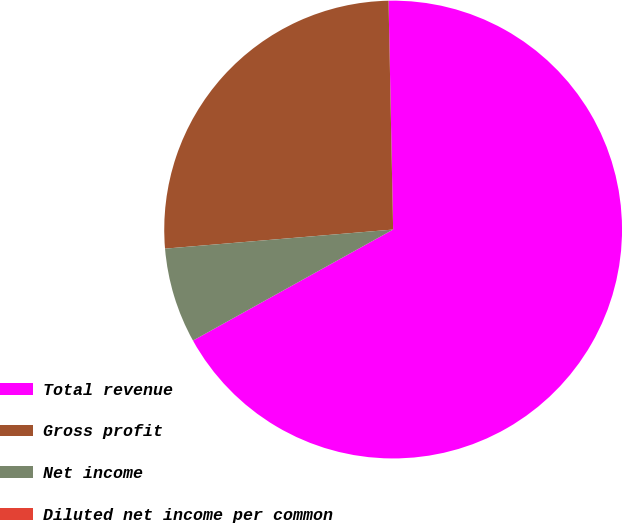Convert chart to OTSL. <chart><loc_0><loc_0><loc_500><loc_500><pie_chart><fcel>Total revenue<fcel>Gross profit<fcel>Net income<fcel>Diluted net income per common<nl><fcel>67.26%<fcel>26.01%<fcel>6.73%<fcel>0.0%<nl></chart> 